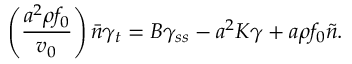<formula> <loc_0><loc_0><loc_500><loc_500>\left ( \frac { a ^ { 2 } \rho f _ { 0 } } { v _ { 0 } } \right ) \bar { n } \gamma _ { t } = B \gamma _ { s s } - a ^ { 2 } K \gamma + a \rho f _ { 0 } \tilde { n } .</formula> 